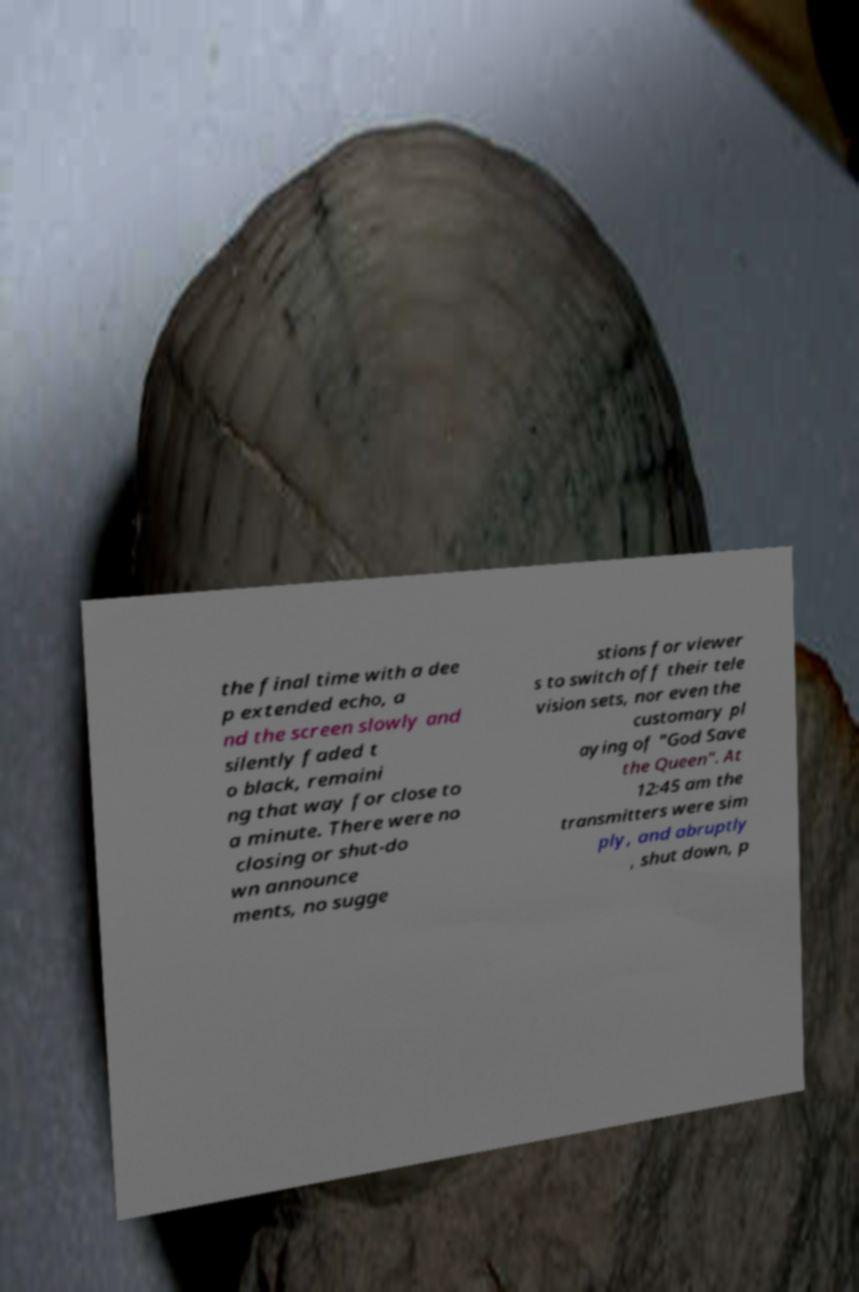For documentation purposes, I need the text within this image transcribed. Could you provide that? the final time with a dee p extended echo, a nd the screen slowly and silently faded t o black, remaini ng that way for close to a minute. There were no closing or shut-do wn announce ments, no sugge stions for viewer s to switch off their tele vision sets, nor even the customary pl aying of "God Save the Queen". At 12:45 am the transmitters were sim ply, and abruptly , shut down, p 